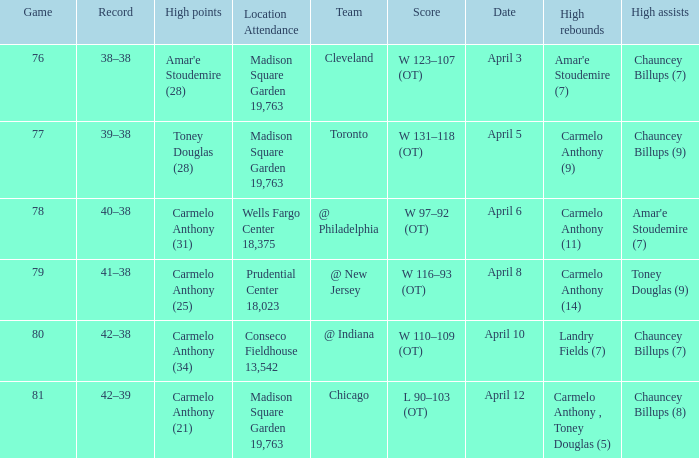Name the high assists for madison square garden 19,763 and record is 39–38 Chauncey Billups (9). 